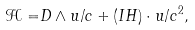Convert formula to latex. <formula><loc_0><loc_0><loc_500><loc_500>\mathcal { H = } D \wedge u / c + ( I H ) \cdot u / c ^ { 2 } ,</formula> 